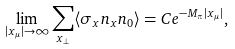<formula> <loc_0><loc_0><loc_500><loc_500>\lim _ { | x _ { \mu } | \rightarrow \infty } \sum _ { x _ { \perp } } \langle \sigma _ { x } n _ { x } n _ { 0 } \rangle = C e ^ { - M _ { \pi } | x _ { \mu } | } ,</formula> 